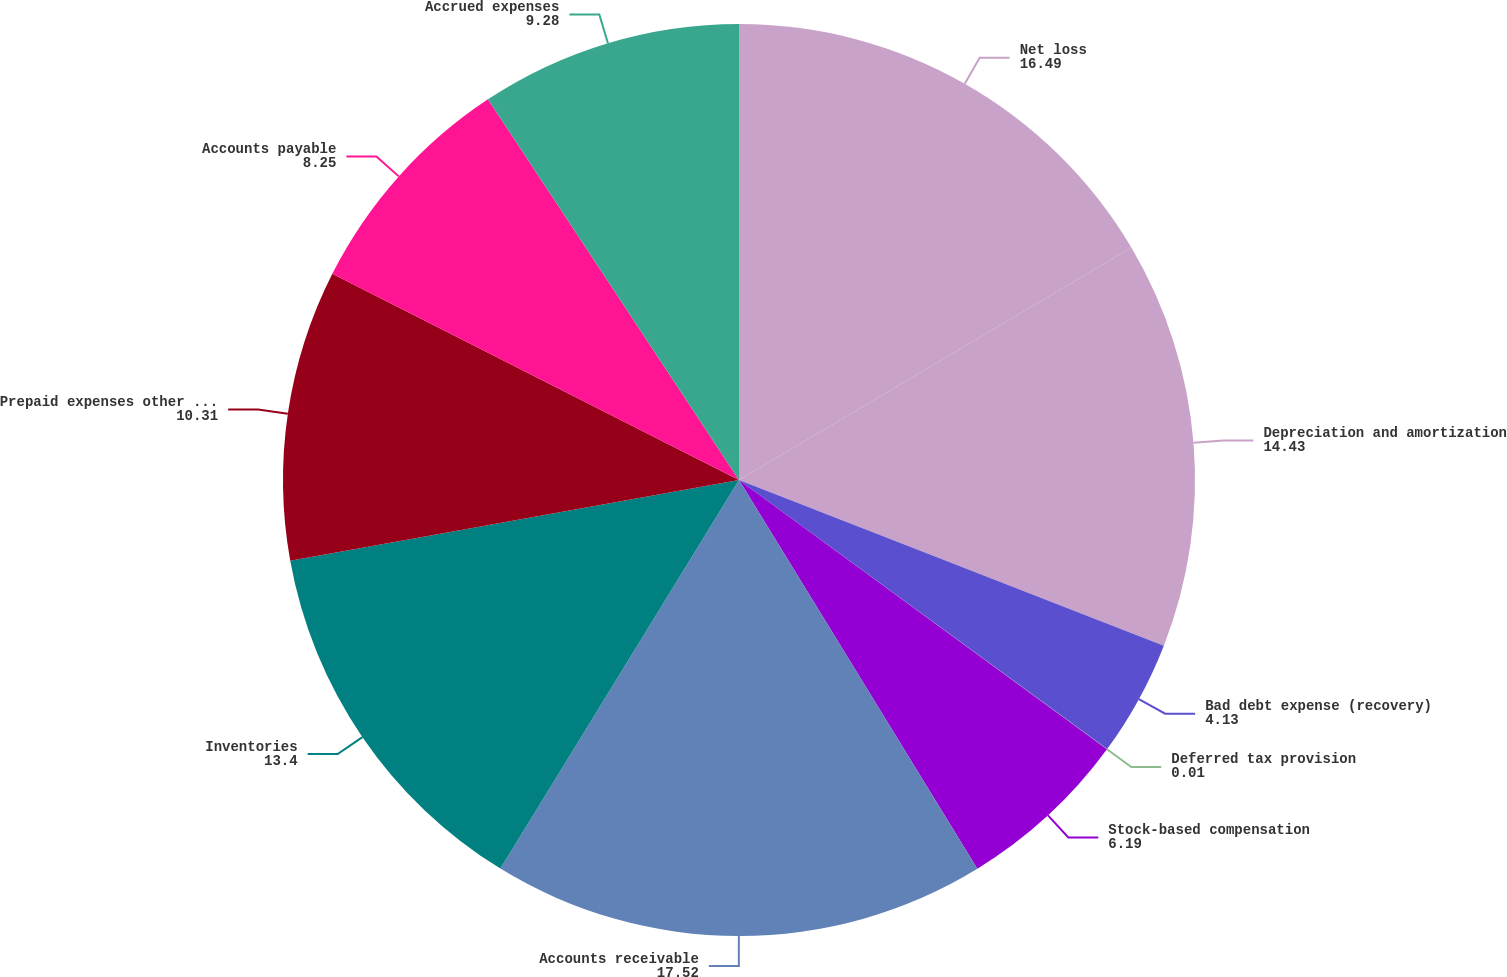Convert chart to OTSL. <chart><loc_0><loc_0><loc_500><loc_500><pie_chart><fcel>Net loss<fcel>Depreciation and amortization<fcel>Bad debt expense (recovery)<fcel>Deferred tax provision<fcel>Stock-based compensation<fcel>Accounts receivable<fcel>Inventories<fcel>Prepaid expenses other current<fcel>Accounts payable<fcel>Accrued expenses<nl><fcel>16.49%<fcel>14.43%<fcel>4.13%<fcel>0.01%<fcel>6.19%<fcel>17.52%<fcel>13.4%<fcel>10.31%<fcel>8.25%<fcel>9.28%<nl></chart> 